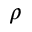<formula> <loc_0><loc_0><loc_500><loc_500>\rho</formula> 